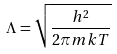<formula> <loc_0><loc_0><loc_500><loc_500>\Lambda = \sqrt { \frac { h ^ { 2 } } { 2 \pi m k T } }</formula> 